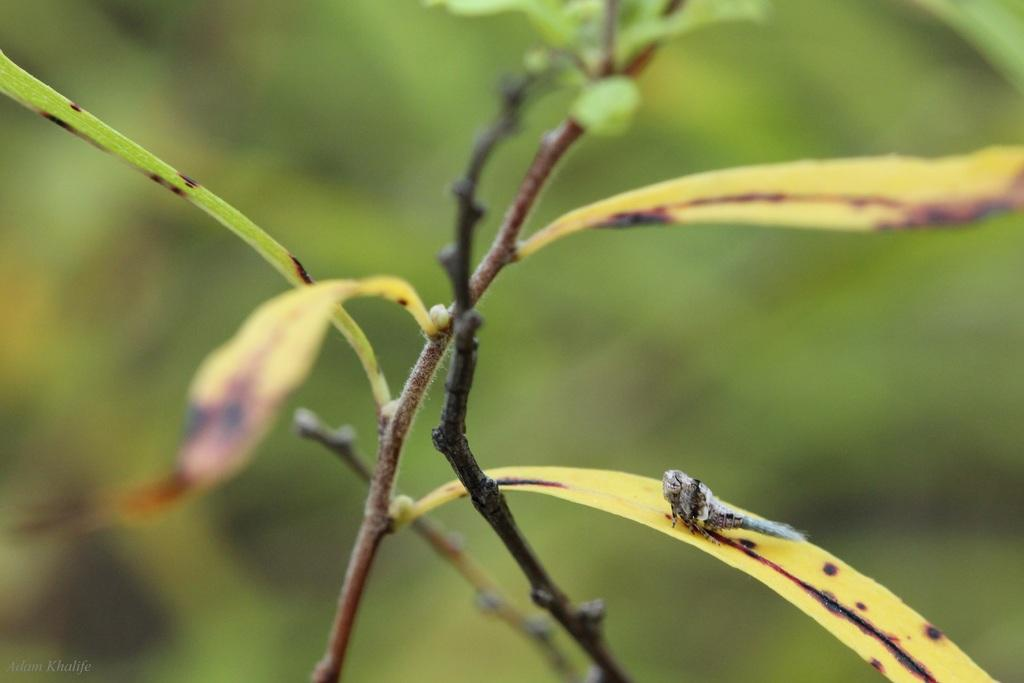What is located in the front of the image? There is a plant in the front of the image. Can you describe the background of the image? The background of the image is blurry. Can you see the coast in the background of the image? There is no coast visible in the background of the image. What type of thrill can be experienced by the plant in the image? The plant in the image is not experiencing any thrill, as it is an inanimate object. 